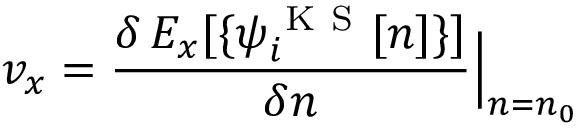Convert formula to latex. <formula><loc_0><loc_0><loc_500><loc_500>v _ { x } = \frac { \delta \, E _ { x } [ \{ \psi _ { i } ^ { K S } [ n ] \} ] } { \delta n } \Big | _ { n = n _ { 0 } }</formula> 